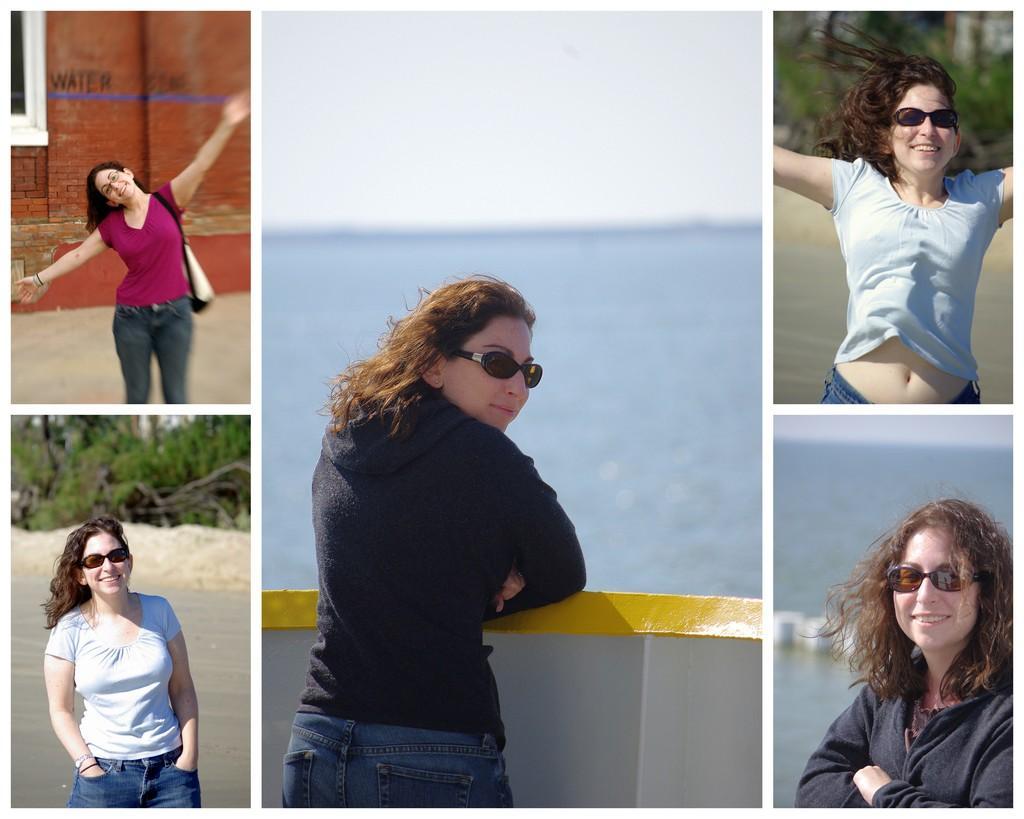How would you summarize this image in a sentence or two? In this image we can see a collage. In the left top image we can see a lady wearing bag. In the background there is a brick wall. In the left bottom image there is a lady wearing goggles. In the background there are trees and water. In the middle image there is a lady wearing goggles and standing near to a wall. In the back there is water and sky. In the right top image there is a lady wearing goggles. In the background there are trees and water. In the right bottom image there is a lady wearing goggles. In the background there is water. 